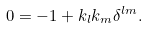<formula> <loc_0><loc_0><loc_500><loc_500>0 = - 1 + k _ { l } k _ { m } \delta ^ { l m } .</formula> 